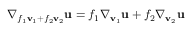<formula> <loc_0><loc_0><loc_500><loc_500>\nabla _ { f _ { 1 } v _ { 1 } + f _ { 2 } v _ { 2 } } u = f _ { 1 } \nabla _ { v _ { 1 } } u + f _ { 2 } \nabla _ { v _ { 2 } } u</formula> 